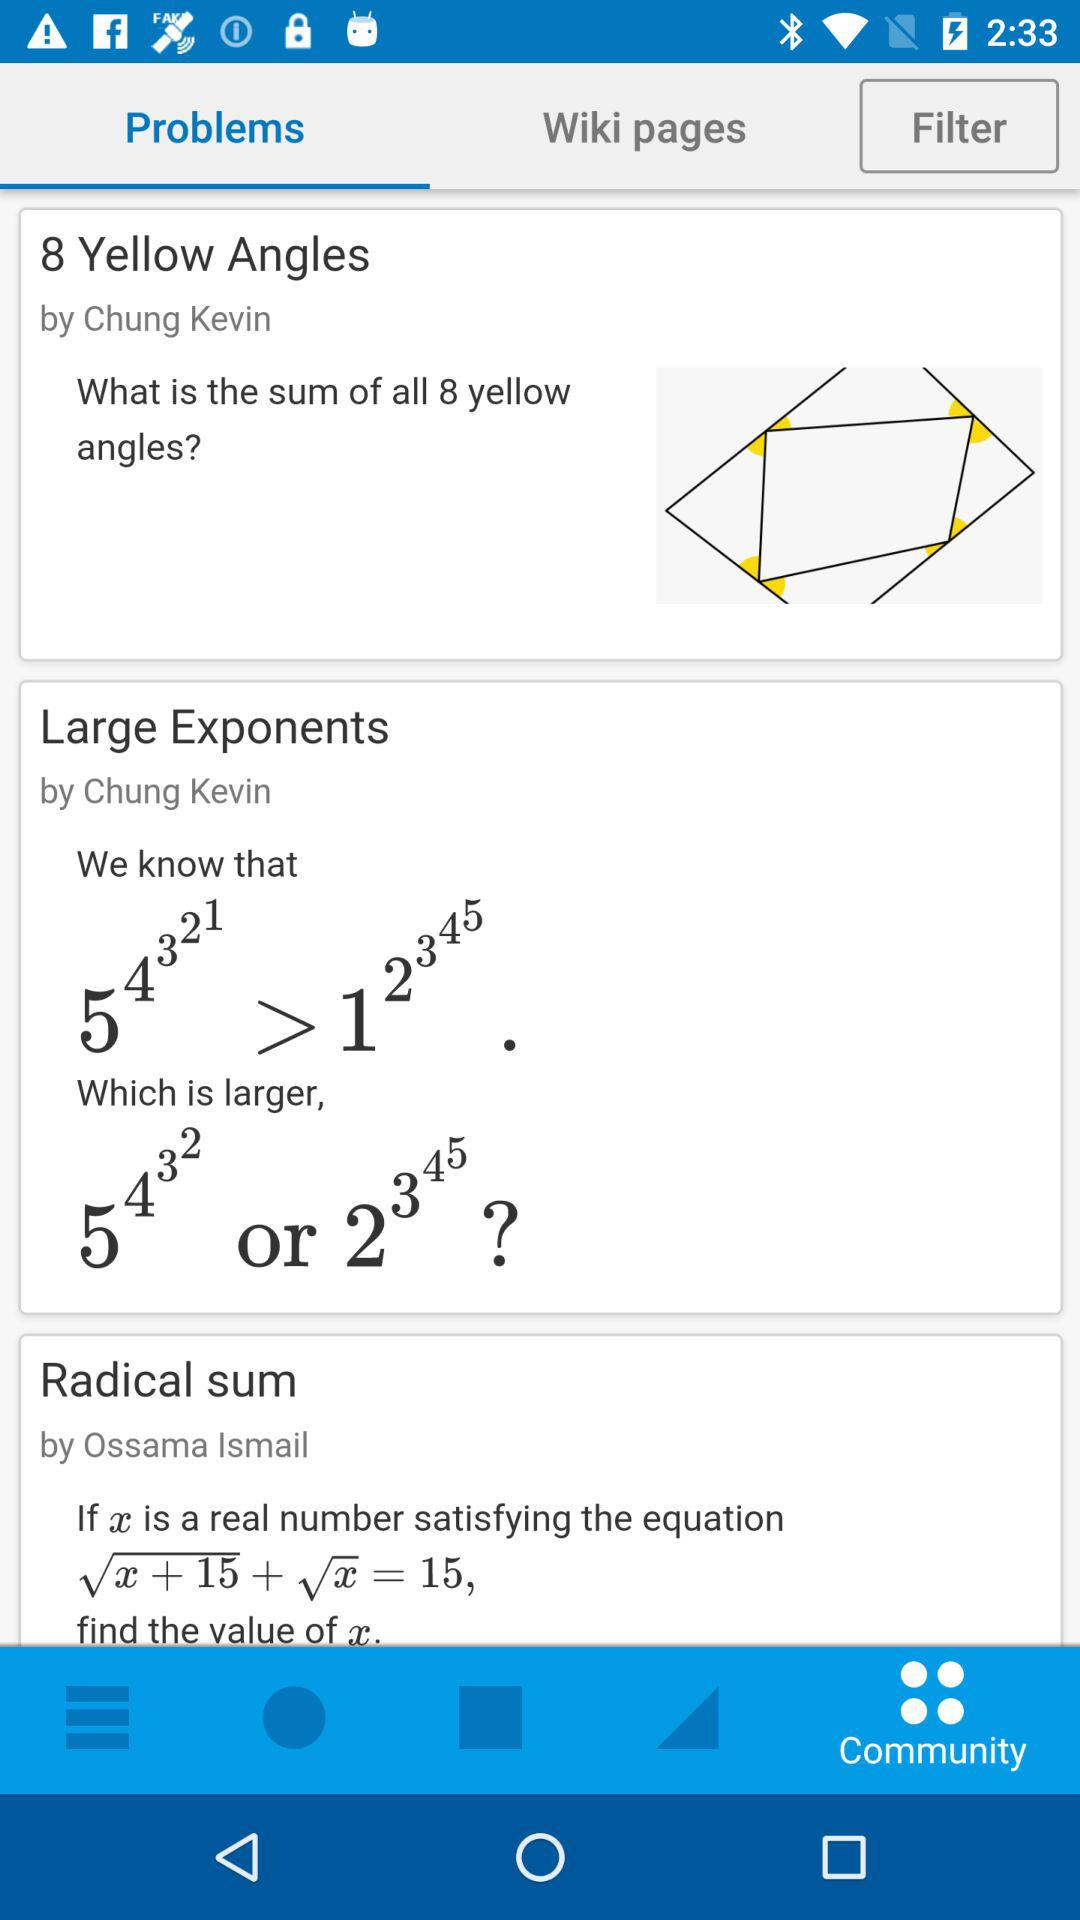Which tab is selected? The selected tab is "Problems". 